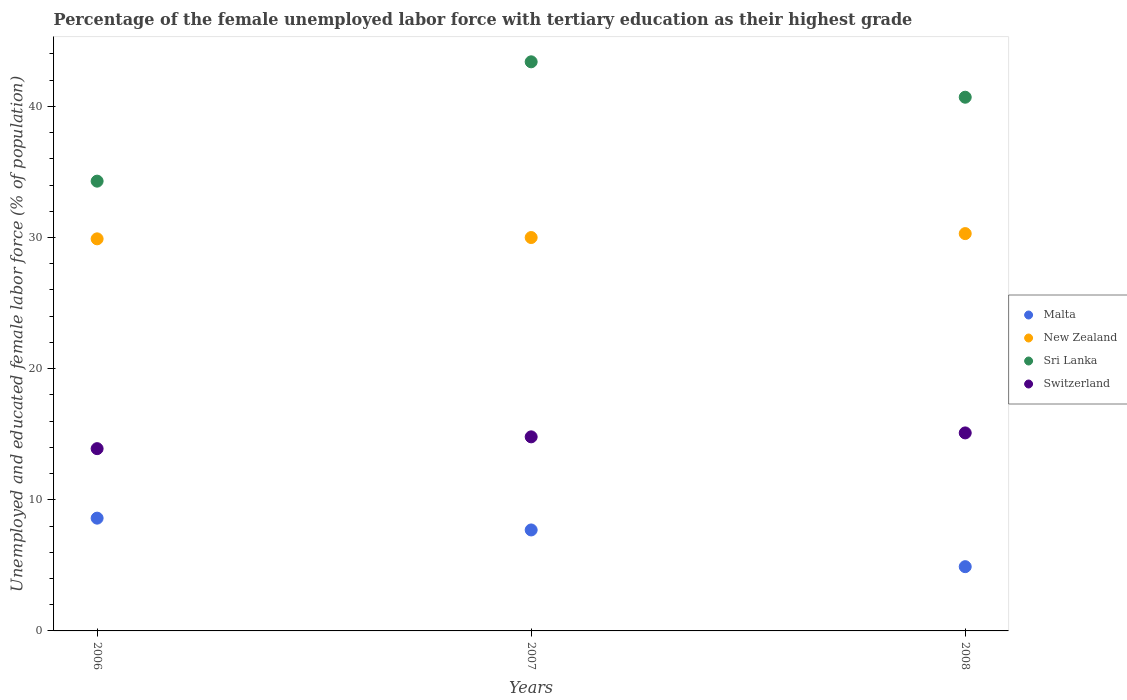How many different coloured dotlines are there?
Provide a succinct answer. 4. What is the percentage of the unemployed female labor force with tertiary education in Malta in 2008?
Your response must be concise. 4.9. Across all years, what is the maximum percentage of the unemployed female labor force with tertiary education in Malta?
Offer a very short reply. 8.6. Across all years, what is the minimum percentage of the unemployed female labor force with tertiary education in New Zealand?
Your response must be concise. 29.9. In which year was the percentage of the unemployed female labor force with tertiary education in Malta maximum?
Provide a short and direct response. 2006. In which year was the percentage of the unemployed female labor force with tertiary education in Sri Lanka minimum?
Offer a terse response. 2006. What is the total percentage of the unemployed female labor force with tertiary education in Sri Lanka in the graph?
Your answer should be very brief. 118.4. What is the difference between the percentage of the unemployed female labor force with tertiary education in Malta in 2006 and that in 2008?
Offer a terse response. 3.7. What is the difference between the percentage of the unemployed female labor force with tertiary education in Switzerland in 2006 and the percentage of the unemployed female labor force with tertiary education in Malta in 2007?
Make the answer very short. 6.2. What is the average percentage of the unemployed female labor force with tertiary education in Malta per year?
Your answer should be very brief. 7.07. In the year 2008, what is the difference between the percentage of the unemployed female labor force with tertiary education in Switzerland and percentage of the unemployed female labor force with tertiary education in Malta?
Give a very brief answer. 10.2. What is the ratio of the percentage of the unemployed female labor force with tertiary education in Switzerland in 2006 to that in 2007?
Your answer should be compact. 0.94. What is the difference between the highest and the second highest percentage of the unemployed female labor force with tertiary education in Malta?
Make the answer very short. 0.9. What is the difference between the highest and the lowest percentage of the unemployed female labor force with tertiary education in Malta?
Make the answer very short. 3.7. Is the sum of the percentage of the unemployed female labor force with tertiary education in Sri Lanka in 2006 and 2007 greater than the maximum percentage of the unemployed female labor force with tertiary education in Switzerland across all years?
Your response must be concise. Yes. Is it the case that in every year, the sum of the percentage of the unemployed female labor force with tertiary education in Sri Lanka and percentage of the unemployed female labor force with tertiary education in Malta  is greater than the percentage of the unemployed female labor force with tertiary education in Switzerland?
Your answer should be compact. Yes. Does the percentage of the unemployed female labor force with tertiary education in New Zealand monotonically increase over the years?
Your response must be concise. Yes. How many dotlines are there?
Provide a short and direct response. 4. Does the graph contain any zero values?
Your answer should be very brief. No. Does the graph contain grids?
Provide a succinct answer. No. How many legend labels are there?
Ensure brevity in your answer.  4. What is the title of the graph?
Keep it short and to the point. Percentage of the female unemployed labor force with tertiary education as their highest grade. What is the label or title of the X-axis?
Make the answer very short. Years. What is the label or title of the Y-axis?
Give a very brief answer. Unemployed and educated female labor force (% of population). What is the Unemployed and educated female labor force (% of population) in Malta in 2006?
Your answer should be compact. 8.6. What is the Unemployed and educated female labor force (% of population) of New Zealand in 2006?
Ensure brevity in your answer.  29.9. What is the Unemployed and educated female labor force (% of population) in Sri Lanka in 2006?
Offer a very short reply. 34.3. What is the Unemployed and educated female labor force (% of population) of Switzerland in 2006?
Provide a succinct answer. 13.9. What is the Unemployed and educated female labor force (% of population) in Malta in 2007?
Provide a short and direct response. 7.7. What is the Unemployed and educated female labor force (% of population) of New Zealand in 2007?
Provide a succinct answer. 30. What is the Unemployed and educated female labor force (% of population) in Sri Lanka in 2007?
Offer a terse response. 43.4. What is the Unemployed and educated female labor force (% of population) of Switzerland in 2007?
Give a very brief answer. 14.8. What is the Unemployed and educated female labor force (% of population) of Malta in 2008?
Offer a very short reply. 4.9. What is the Unemployed and educated female labor force (% of population) in New Zealand in 2008?
Your answer should be very brief. 30.3. What is the Unemployed and educated female labor force (% of population) in Sri Lanka in 2008?
Ensure brevity in your answer.  40.7. What is the Unemployed and educated female labor force (% of population) of Switzerland in 2008?
Provide a succinct answer. 15.1. Across all years, what is the maximum Unemployed and educated female labor force (% of population) in Malta?
Make the answer very short. 8.6. Across all years, what is the maximum Unemployed and educated female labor force (% of population) of New Zealand?
Your response must be concise. 30.3. Across all years, what is the maximum Unemployed and educated female labor force (% of population) of Sri Lanka?
Give a very brief answer. 43.4. Across all years, what is the maximum Unemployed and educated female labor force (% of population) of Switzerland?
Provide a short and direct response. 15.1. Across all years, what is the minimum Unemployed and educated female labor force (% of population) of Malta?
Provide a succinct answer. 4.9. Across all years, what is the minimum Unemployed and educated female labor force (% of population) in New Zealand?
Your answer should be very brief. 29.9. Across all years, what is the minimum Unemployed and educated female labor force (% of population) in Sri Lanka?
Provide a succinct answer. 34.3. Across all years, what is the minimum Unemployed and educated female labor force (% of population) of Switzerland?
Your response must be concise. 13.9. What is the total Unemployed and educated female labor force (% of population) in Malta in the graph?
Provide a short and direct response. 21.2. What is the total Unemployed and educated female labor force (% of population) of New Zealand in the graph?
Provide a short and direct response. 90.2. What is the total Unemployed and educated female labor force (% of population) of Sri Lanka in the graph?
Your answer should be very brief. 118.4. What is the total Unemployed and educated female labor force (% of population) of Switzerland in the graph?
Ensure brevity in your answer.  43.8. What is the difference between the Unemployed and educated female labor force (% of population) in New Zealand in 2006 and that in 2007?
Ensure brevity in your answer.  -0.1. What is the difference between the Unemployed and educated female labor force (% of population) of Switzerland in 2006 and that in 2007?
Provide a short and direct response. -0.9. What is the difference between the Unemployed and educated female labor force (% of population) of Malta in 2006 and that in 2008?
Your response must be concise. 3.7. What is the difference between the Unemployed and educated female labor force (% of population) in Sri Lanka in 2006 and that in 2008?
Provide a succinct answer. -6.4. What is the difference between the Unemployed and educated female labor force (% of population) of Switzerland in 2006 and that in 2008?
Make the answer very short. -1.2. What is the difference between the Unemployed and educated female labor force (% of population) in Sri Lanka in 2007 and that in 2008?
Ensure brevity in your answer.  2.7. What is the difference between the Unemployed and educated female labor force (% of population) of Switzerland in 2007 and that in 2008?
Provide a succinct answer. -0.3. What is the difference between the Unemployed and educated female labor force (% of population) of Malta in 2006 and the Unemployed and educated female labor force (% of population) of New Zealand in 2007?
Your response must be concise. -21.4. What is the difference between the Unemployed and educated female labor force (% of population) of Malta in 2006 and the Unemployed and educated female labor force (% of population) of Sri Lanka in 2007?
Your answer should be compact. -34.8. What is the difference between the Unemployed and educated female labor force (% of population) in Malta in 2006 and the Unemployed and educated female labor force (% of population) in Switzerland in 2007?
Your response must be concise. -6.2. What is the difference between the Unemployed and educated female labor force (% of population) in New Zealand in 2006 and the Unemployed and educated female labor force (% of population) in Sri Lanka in 2007?
Give a very brief answer. -13.5. What is the difference between the Unemployed and educated female labor force (% of population) in New Zealand in 2006 and the Unemployed and educated female labor force (% of population) in Switzerland in 2007?
Give a very brief answer. 15.1. What is the difference between the Unemployed and educated female labor force (% of population) of Sri Lanka in 2006 and the Unemployed and educated female labor force (% of population) of Switzerland in 2007?
Keep it short and to the point. 19.5. What is the difference between the Unemployed and educated female labor force (% of population) in Malta in 2006 and the Unemployed and educated female labor force (% of population) in New Zealand in 2008?
Keep it short and to the point. -21.7. What is the difference between the Unemployed and educated female labor force (% of population) of Malta in 2006 and the Unemployed and educated female labor force (% of population) of Sri Lanka in 2008?
Your response must be concise. -32.1. What is the difference between the Unemployed and educated female labor force (% of population) of Malta in 2006 and the Unemployed and educated female labor force (% of population) of Switzerland in 2008?
Offer a very short reply. -6.5. What is the difference between the Unemployed and educated female labor force (% of population) of New Zealand in 2006 and the Unemployed and educated female labor force (% of population) of Switzerland in 2008?
Give a very brief answer. 14.8. What is the difference between the Unemployed and educated female labor force (% of population) in Malta in 2007 and the Unemployed and educated female labor force (% of population) in New Zealand in 2008?
Give a very brief answer. -22.6. What is the difference between the Unemployed and educated female labor force (% of population) in Malta in 2007 and the Unemployed and educated female labor force (% of population) in Sri Lanka in 2008?
Make the answer very short. -33. What is the difference between the Unemployed and educated female labor force (% of population) of New Zealand in 2007 and the Unemployed and educated female labor force (% of population) of Switzerland in 2008?
Your answer should be compact. 14.9. What is the difference between the Unemployed and educated female labor force (% of population) of Sri Lanka in 2007 and the Unemployed and educated female labor force (% of population) of Switzerland in 2008?
Give a very brief answer. 28.3. What is the average Unemployed and educated female labor force (% of population) of Malta per year?
Offer a terse response. 7.07. What is the average Unemployed and educated female labor force (% of population) of New Zealand per year?
Keep it short and to the point. 30.07. What is the average Unemployed and educated female labor force (% of population) in Sri Lanka per year?
Give a very brief answer. 39.47. What is the average Unemployed and educated female labor force (% of population) of Switzerland per year?
Ensure brevity in your answer.  14.6. In the year 2006, what is the difference between the Unemployed and educated female labor force (% of population) in Malta and Unemployed and educated female labor force (% of population) in New Zealand?
Your answer should be compact. -21.3. In the year 2006, what is the difference between the Unemployed and educated female labor force (% of population) of Malta and Unemployed and educated female labor force (% of population) of Sri Lanka?
Offer a terse response. -25.7. In the year 2006, what is the difference between the Unemployed and educated female labor force (% of population) in Sri Lanka and Unemployed and educated female labor force (% of population) in Switzerland?
Give a very brief answer. 20.4. In the year 2007, what is the difference between the Unemployed and educated female labor force (% of population) in Malta and Unemployed and educated female labor force (% of population) in New Zealand?
Ensure brevity in your answer.  -22.3. In the year 2007, what is the difference between the Unemployed and educated female labor force (% of population) of Malta and Unemployed and educated female labor force (% of population) of Sri Lanka?
Provide a short and direct response. -35.7. In the year 2007, what is the difference between the Unemployed and educated female labor force (% of population) in Malta and Unemployed and educated female labor force (% of population) in Switzerland?
Offer a terse response. -7.1. In the year 2007, what is the difference between the Unemployed and educated female labor force (% of population) of New Zealand and Unemployed and educated female labor force (% of population) of Switzerland?
Your response must be concise. 15.2. In the year 2007, what is the difference between the Unemployed and educated female labor force (% of population) in Sri Lanka and Unemployed and educated female labor force (% of population) in Switzerland?
Provide a succinct answer. 28.6. In the year 2008, what is the difference between the Unemployed and educated female labor force (% of population) in Malta and Unemployed and educated female labor force (% of population) in New Zealand?
Give a very brief answer. -25.4. In the year 2008, what is the difference between the Unemployed and educated female labor force (% of population) in Malta and Unemployed and educated female labor force (% of population) in Sri Lanka?
Keep it short and to the point. -35.8. In the year 2008, what is the difference between the Unemployed and educated female labor force (% of population) of Malta and Unemployed and educated female labor force (% of population) of Switzerland?
Provide a succinct answer. -10.2. In the year 2008, what is the difference between the Unemployed and educated female labor force (% of population) of New Zealand and Unemployed and educated female labor force (% of population) of Sri Lanka?
Your response must be concise. -10.4. In the year 2008, what is the difference between the Unemployed and educated female labor force (% of population) of Sri Lanka and Unemployed and educated female labor force (% of population) of Switzerland?
Your answer should be compact. 25.6. What is the ratio of the Unemployed and educated female labor force (% of population) in Malta in 2006 to that in 2007?
Give a very brief answer. 1.12. What is the ratio of the Unemployed and educated female labor force (% of population) of Sri Lanka in 2006 to that in 2007?
Make the answer very short. 0.79. What is the ratio of the Unemployed and educated female labor force (% of population) of Switzerland in 2006 to that in 2007?
Keep it short and to the point. 0.94. What is the ratio of the Unemployed and educated female labor force (% of population) in Malta in 2006 to that in 2008?
Keep it short and to the point. 1.76. What is the ratio of the Unemployed and educated female labor force (% of population) in New Zealand in 2006 to that in 2008?
Make the answer very short. 0.99. What is the ratio of the Unemployed and educated female labor force (% of population) of Sri Lanka in 2006 to that in 2008?
Your response must be concise. 0.84. What is the ratio of the Unemployed and educated female labor force (% of population) in Switzerland in 2006 to that in 2008?
Your answer should be very brief. 0.92. What is the ratio of the Unemployed and educated female labor force (% of population) in Malta in 2007 to that in 2008?
Keep it short and to the point. 1.57. What is the ratio of the Unemployed and educated female labor force (% of population) in New Zealand in 2007 to that in 2008?
Provide a succinct answer. 0.99. What is the ratio of the Unemployed and educated female labor force (% of population) of Sri Lanka in 2007 to that in 2008?
Offer a terse response. 1.07. What is the ratio of the Unemployed and educated female labor force (% of population) in Switzerland in 2007 to that in 2008?
Give a very brief answer. 0.98. What is the difference between the highest and the second highest Unemployed and educated female labor force (% of population) in Sri Lanka?
Your answer should be compact. 2.7. What is the difference between the highest and the second highest Unemployed and educated female labor force (% of population) of Switzerland?
Your answer should be compact. 0.3. What is the difference between the highest and the lowest Unemployed and educated female labor force (% of population) in Malta?
Ensure brevity in your answer.  3.7. What is the difference between the highest and the lowest Unemployed and educated female labor force (% of population) in Switzerland?
Your response must be concise. 1.2. 